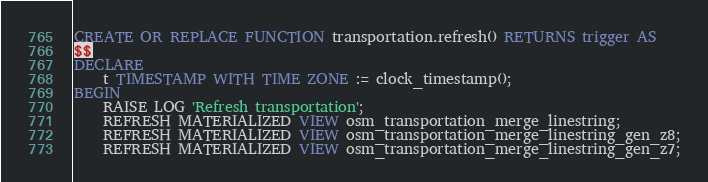Convert code to text. <code><loc_0><loc_0><loc_500><loc_500><_SQL_>CREATE OR REPLACE FUNCTION transportation.refresh() RETURNS trigger AS
$$
DECLARE
    t TIMESTAMP WITH TIME ZONE := clock_timestamp();
BEGIN
    RAISE LOG 'Refresh transportation';
    REFRESH MATERIALIZED VIEW osm_transportation_merge_linestring;
    REFRESH MATERIALIZED VIEW osm_transportation_merge_linestring_gen_z8;
    REFRESH MATERIALIZED VIEW osm_transportation_merge_linestring_gen_z7;</code> 